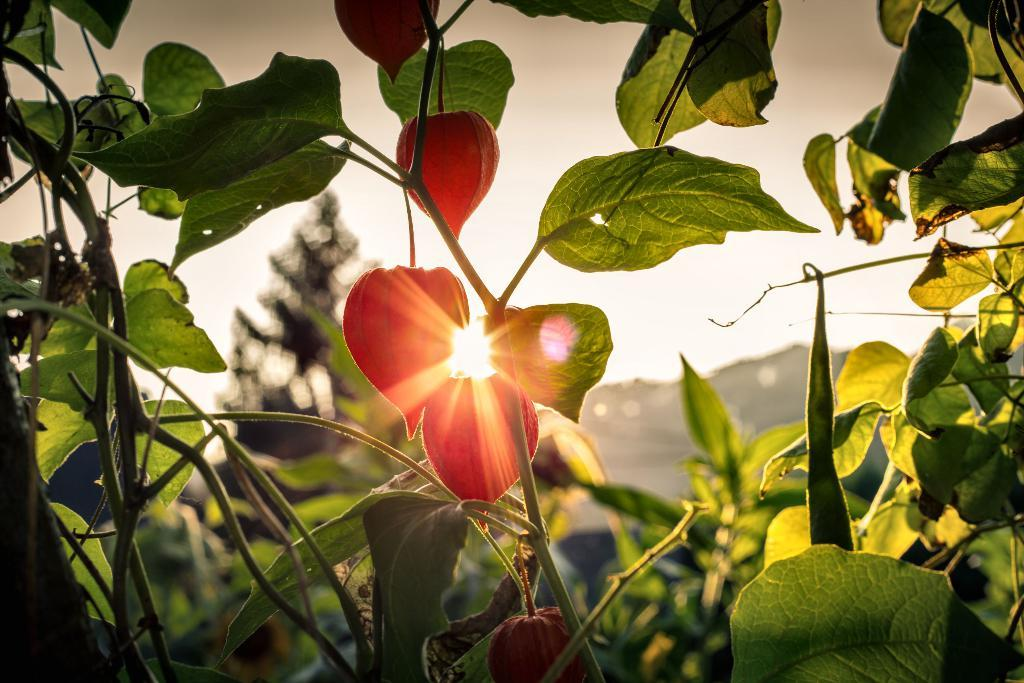What type of living organisms can be seen in the image? There are flowers and plants visible in the image. What can be seen in the background of the image? The sky is visible in the background of the image. How would you describe the background of the picture? The background of the picture appears blurry. What type of army can be seen marching in the image? There is no army present in the image; it features flowers, plants, and a blurry sky background. Can you describe the beetle crawling on the leaves in the image? There is no beetle present in the image; it only contains flowers and plants. 